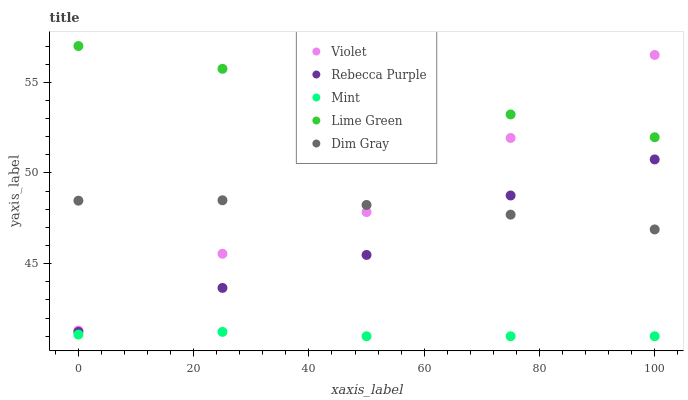Does Mint have the minimum area under the curve?
Answer yes or no. Yes. Does Lime Green have the maximum area under the curve?
Answer yes or no. Yes. Does Dim Gray have the minimum area under the curve?
Answer yes or no. No. Does Dim Gray have the maximum area under the curve?
Answer yes or no. No. Is Lime Green the smoothest?
Answer yes or no. Yes. Is Violet the roughest?
Answer yes or no. Yes. Is Dim Gray the smoothest?
Answer yes or no. No. Is Dim Gray the roughest?
Answer yes or no. No. Does Mint have the lowest value?
Answer yes or no. Yes. Does Dim Gray have the lowest value?
Answer yes or no. No. Does Lime Green have the highest value?
Answer yes or no. Yes. Does Dim Gray have the highest value?
Answer yes or no. No. Is Mint less than Dim Gray?
Answer yes or no. Yes. Is Lime Green greater than Rebecca Purple?
Answer yes or no. Yes. Does Rebecca Purple intersect Dim Gray?
Answer yes or no. Yes. Is Rebecca Purple less than Dim Gray?
Answer yes or no. No. Is Rebecca Purple greater than Dim Gray?
Answer yes or no. No. Does Mint intersect Dim Gray?
Answer yes or no. No. 